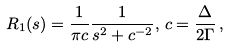Convert formula to latex. <formula><loc_0><loc_0><loc_500><loc_500>R _ { 1 } ( s ) = \frac { 1 } { \pi c } \frac { 1 } { s ^ { 2 } + c ^ { - 2 } } , \, c = \frac { \Delta } { 2 \Gamma } \, ,</formula> 